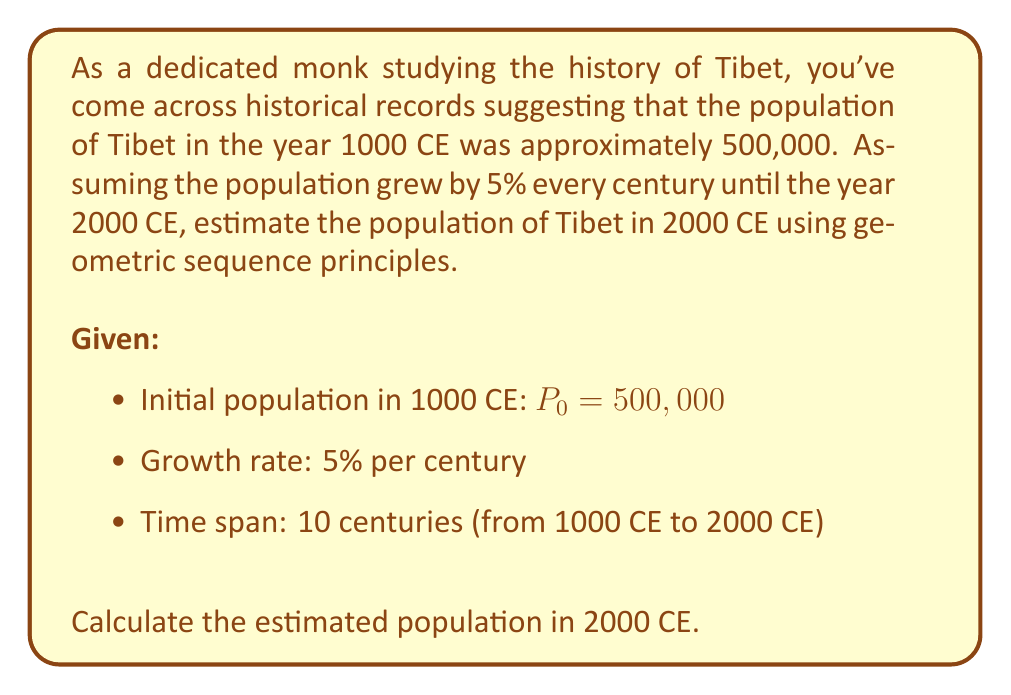Help me with this question. Let's approach this step-by-step using the principles of geometric sequences:

1) First, we identify the components of our geometric sequence:
   - Initial term (population in 1000 CE): $a = 500,000$
   - Common ratio (growth factor per century): $r = 1 + 0.05 = 1.05$
   - Number of terms (centuries): $n = 10$

2) The formula for the nth term of a geometric sequence is:
   $$a_n = a \cdot r^{n-1}$$

3) In our case, we want the 11th term (as the initial population is the 1st term):
   $$P_{2000} = 500,000 \cdot (1.05)^{10}$$

4) Let's calculate this:
   $$P_{2000} = 500,000 \cdot 1.6288946267$$

5) Multiplying:
   $$P_{2000} = 814,447.31335$$

6) Rounding to the nearest whole number (as population is typically expressed in whole numbers):
   $$P_{2000} \approx 814,447$$

Therefore, based on this model, the estimated population of Tibet in 2000 CE would be approximately 814,447 people.
Answer: 814,447 